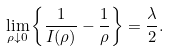<formula> <loc_0><loc_0><loc_500><loc_500>\lim _ { \rho \downarrow 0 } \left \{ \frac { 1 } { I ( \rho ) } - \frac { 1 } { \rho } \right \} = \frac { \lambda } { 2 } .</formula> 